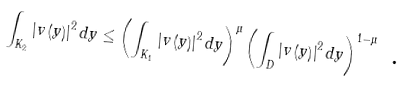<formula> <loc_0><loc_0><loc_500><loc_500>\int _ { K _ { 2 } } \left | v \left ( y \right ) \right | ^ { 2 } d y \leq \left ( \int _ { K _ { 1 } } \left | v \left ( y \right ) \right | ^ { 2 } d y \right ) ^ { \mu } \left ( \int _ { D } \left | v \left ( y \right ) \right | ^ { 2 } d y \right ) ^ { 1 - \mu } \text { .}</formula> 